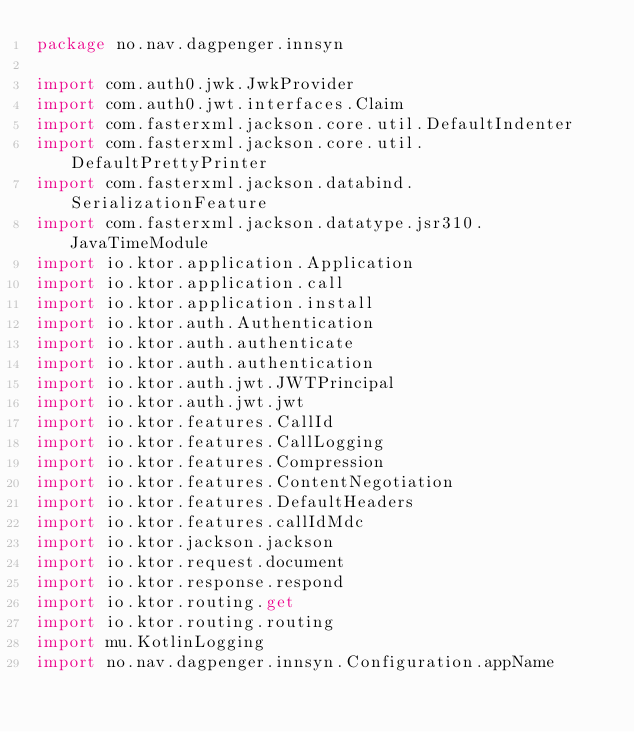<code> <loc_0><loc_0><loc_500><loc_500><_Kotlin_>package no.nav.dagpenger.innsyn

import com.auth0.jwk.JwkProvider
import com.auth0.jwt.interfaces.Claim
import com.fasterxml.jackson.core.util.DefaultIndenter
import com.fasterxml.jackson.core.util.DefaultPrettyPrinter
import com.fasterxml.jackson.databind.SerializationFeature
import com.fasterxml.jackson.datatype.jsr310.JavaTimeModule
import io.ktor.application.Application
import io.ktor.application.call
import io.ktor.application.install
import io.ktor.auth.Authentication
import io.ktor.auth.authenticate
import io.ktor.auth.authentication
import io.ktor.auth.jwt.JWTPrincipal
import io.ktor.auth.jwt.jwt
import io.ktor.features.CallId
import io.ktor.features.CallLogging
import io.ktor.features.Compression
import io.ktor.features.ContentNegotiation
import io.ktor.features.DefaultHeaders
import io.ktor.features.callIdMdc
import io.ktor.jackson.jackson
import io.ktor.request.document
import io.ktor.response.respond
import io.ktor.routing.get
import io.ktor.routing.routing
import mu.KotlinLogging
import no.nav.dagpenger.innsyn.Configuration.appName</code> 